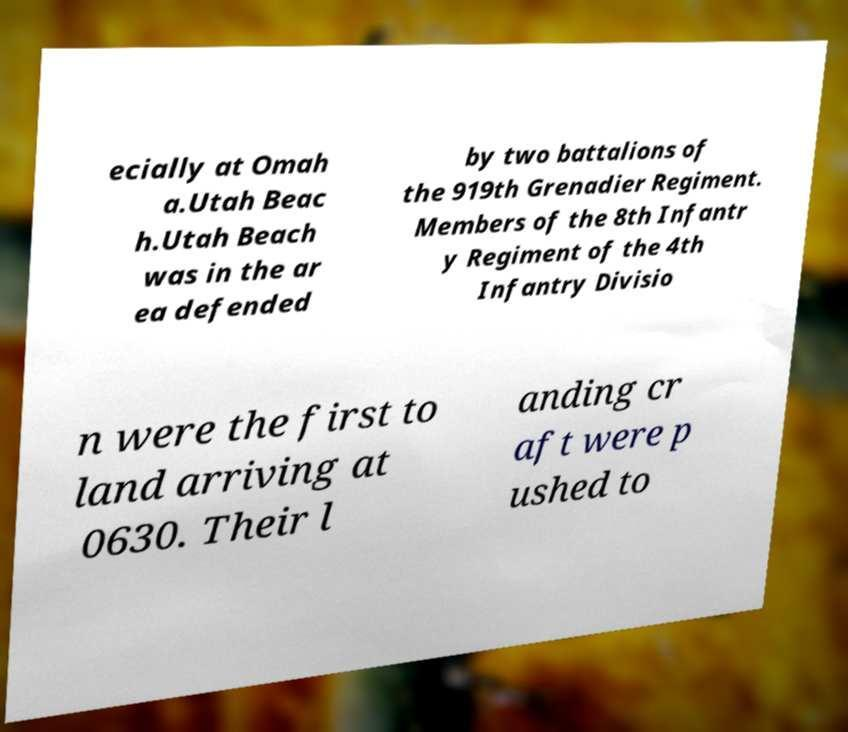Could you assist in decoding the text presented in this image and type it out clearly? ecially at Omah a.Utah Beac h.Utah Beach was in the ar ea defended by two battalions of the 919th Grenadier Regiment. Members of the 8th Infantr y Regiment of the 4th Infantry Divisio n were the first to land arriving at 0630. Their l anding cr aft were p ushed to 